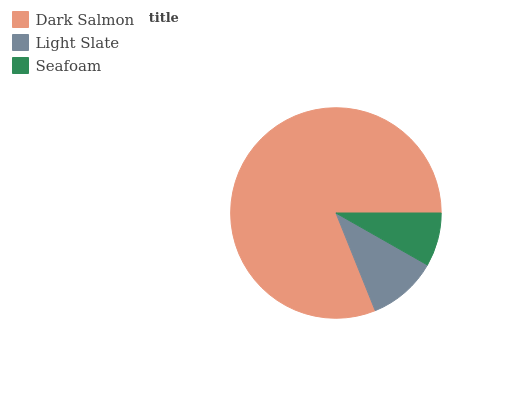Is Seafoam the minimum?
Answer yes or no. Yes. Is Dark Salmon the maximum?
Answer yes or no. Yes. Is Light Slate the minimum?
Answer yes or no. No. Is Light Slate the maximum?
Answer yes or no. No. Is Dark Salmon greater than Light Slate?
Answer yes or no. Yes. Is Light Slate less than Dark Salmon?
Answer yes or no. Yes. Is Light Slate greater than Dark Salmon?
Answer yes or no. No. Is Dark Salmon less than Light Slate?
Answer yes or no. No. Is Light Slate the high median?
Answer yes or no. Yes. Is Light Slate the low median?
Answer yes or no. Yes. Is Dark Salmon the high median?
Answer yes or no. No. Is Dark Salmon the low median?
Answer yes or no. No. 